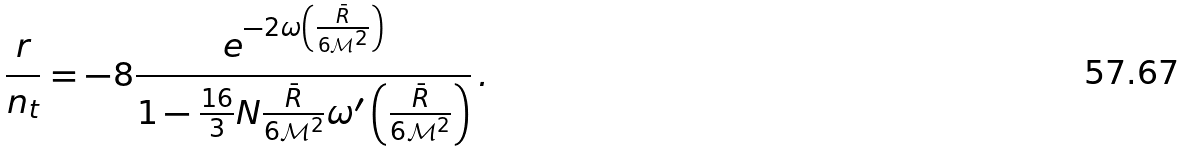<formula> <loc_0><loc_0><loc_500><loc_500>\frac { r } { n _ { t } } = - 8 \frac { e ^ { - 2 \omega \left ( \frac { \bar { R } } { 6 \mathcal { M } ^ { 2 } } \right ) } } { 1 - \frac { 1 6 } 3 N \frac { \bar { R } } { 6 \mathcal { M } ^ { 2 } } \omega ^ { \prime } \left ( \frac { \bar { R } } { 6 \mathcal { M } ^ { 2 } } \right ) } \, .</formula> 